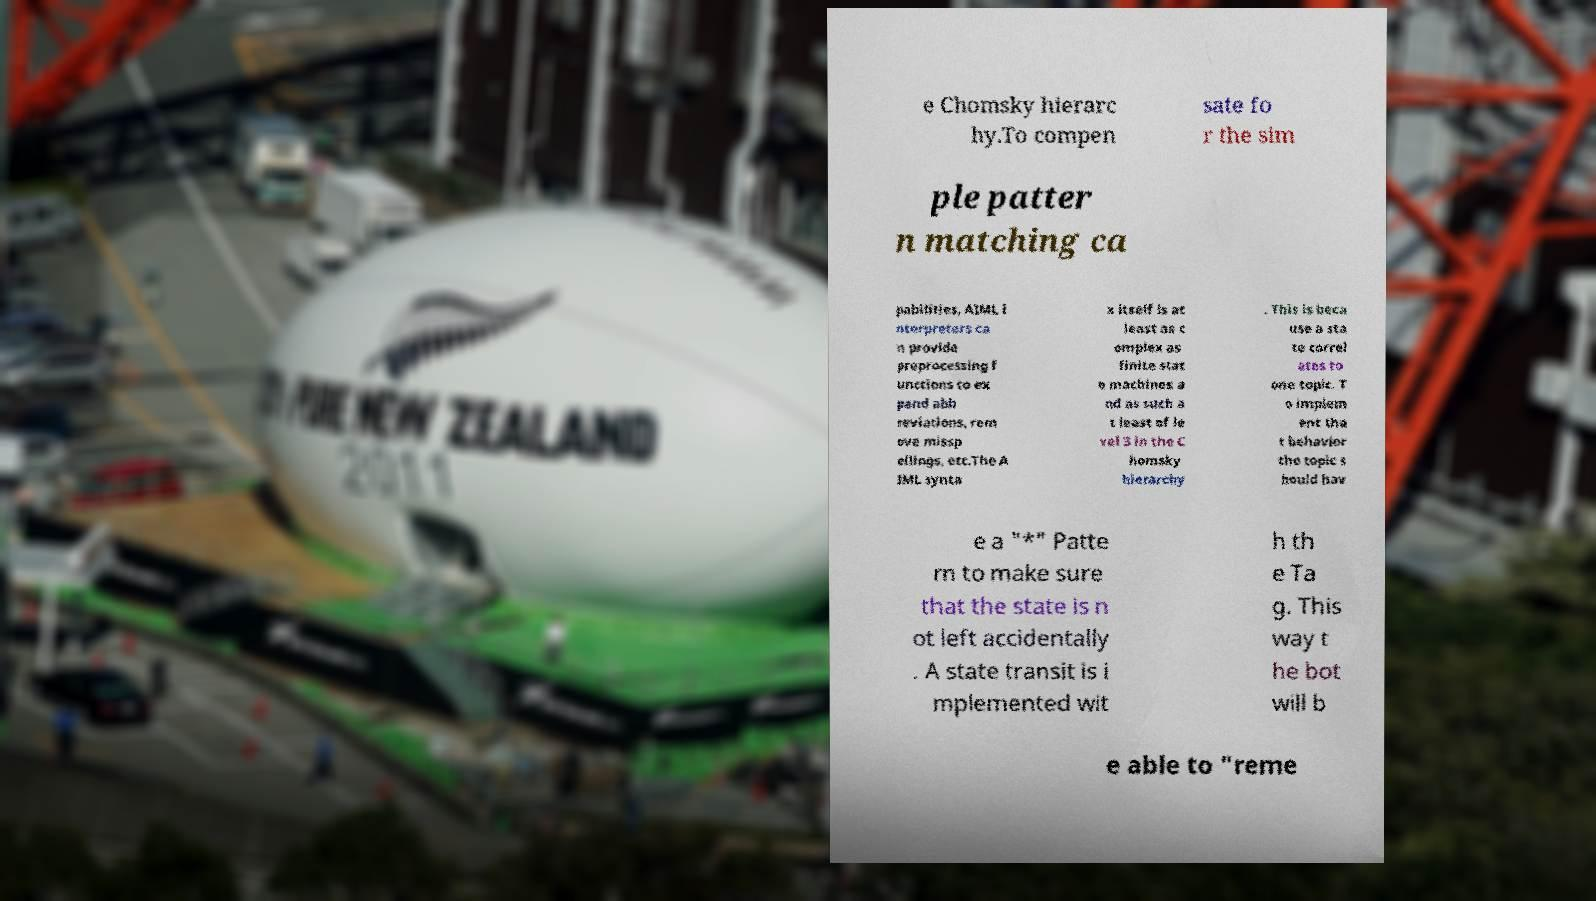For documentation purposes, I need the text within this image transcribed. Could you provide that? e Chomsky hierarc hy.To compen sate fo r the sim ple patter n matching ca pabilities, AIML i nterpreters ca n provide preprocessing f unctions to ex pand abb reviations, rem ove missp ellings, etc.The A IML synta x itself is at least as c omplex as finite stat e machines a nd as such a t least of le vel 3 in the C homsky hierarchy . This is beca use a sta te correl ates to one topic. T o implem ent tha t behavior the topic s hould hav e a "*" Patte rn to make sure that the state is n ot left accidentally . A state transit is i mplemented wit h th e Ta g. This way t he bot will b e able to "reme 